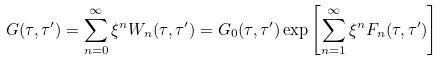<formula> <loc_0><loc_0><loc_500><loc_500>G ( \tau , \tau ^ { \prime } ) = \sum _ { n = 0 } ^ { \infty } \xi ^ { n } W _ { n } ( \tau , \tau ^ { \prime } ) = G _ { 0 } ( \tau , \tau ^ { \prime } ) \exp \left [ \sum _ { n = 1 } ^ { \infty } \xi ^ { n } F _ { n } ( \tau , \tau ^ { \prime } ) \right ]</formula> 